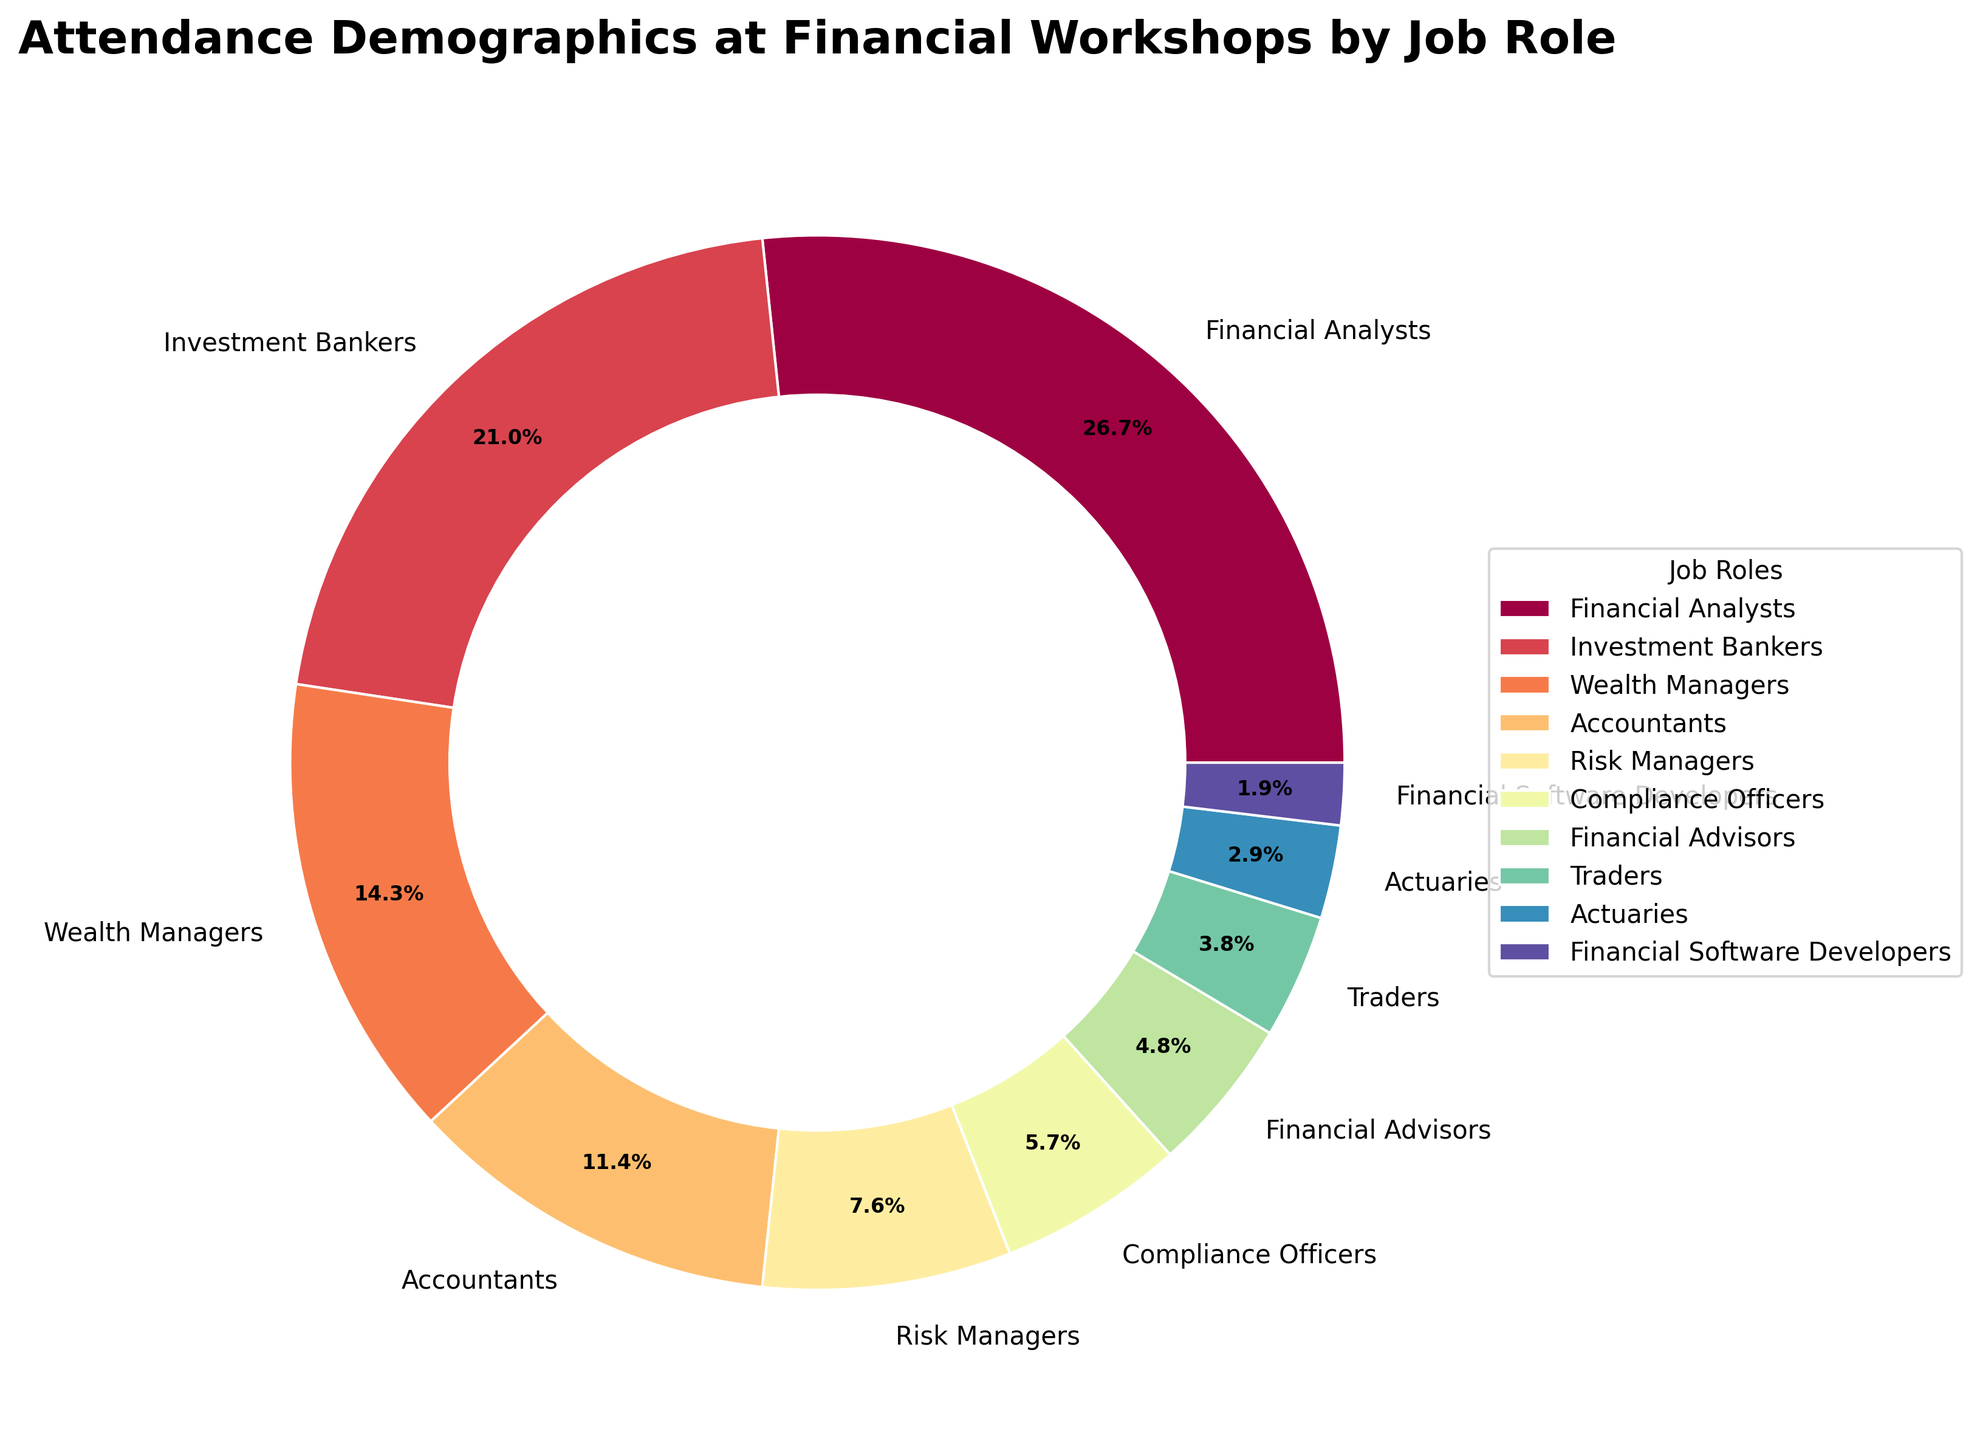What's the percentage of Financial Analysts attending the workshops? From the pie chart, the label next to "Financial Analysts" shows the percentage as 28%. No additional operations or calculations are needed.
Answer: 28% Which job role has the lowest percentage of attendance? From the pie chart, the label with the smallest percentage is "Financial Software Developers" with 2%. This is evident from the size of the wedge and the label associated with it.
Answer: Financial Software Developers What is the combined percentage of Financial Analysts and Investment Bankers? From the pie chart, the percentage of Financial Analysts is 28% and Investment Bankers is 22%. Adding these two percentages together: 28% + 22% = 50%.
Answer: 50% Which job role has a higher attendance percentage: Wealth Managers or Accountants? From the pie chart, the percentage for Wealth Managers is 15% and for Accountants is 12%. Comparing these two values, Wealth Managers have a higher attendance percentage.
Answer: Wealth Managers Are there more Wealth Managers or Compliance Officers attending the workshops? Comparing the percentages from the pie chart, Wealth Managers have 15% while Compliance Officers have 6%. Thus, there are more Wealth Managers attending.
Answer: Wealth Managers What is the total percentage of attendance for job roles with less than 10% each? From the pie chart, the roles with less than 10% attendance are: Risk Managers (8%), Compliance Officers (6%), Financial Advisors (5%), Traders (4%), Actuaries (3%), and Financial Software Developers (2%). Adding these gives: 8% + 6% + 5% + 4% + 3% + 2% = 28%.
Answer: 28% Compare the attendance percentage between Wealth Managers and all job roles with less than 5% attendance combined. Wealth Managers alone have 15%. Job roles with less than 5% attendance are Traders (4%), Actuaries (3%), and Financial Software Developers (2%), combined these percentages are 4% + 3% + 2% = 9%. Thus, Wealth Managers (15%) have a higher attendance than these combined.
Answer: Wealth Managers What's the range of attendance percentages across all job roles? The highest percentage is for Financial Analysts at 28% and the lowest is for Financial Software Developers at 2%. The range is calculated as the difference between the highest and lowest percentages (28% - 2% = 26%).
Answer: 26% Which job role occupies a visually distinct segment near the top of the pie chart based on color? The segments are colored uniquely, and a visual inspection of the segments and their labels shows that Investment Bankers, which is one of the larger segments, has a distinct color and is nearer to the top.
Answer: Investment Bankers Is there a job role with a percentage that is exactly double another job role's percentage? If so, name them. From the pie chart, we can compare the percentages. Wealth Managers have 15% which is exactly double that of Financial Advisors with 5%.
Answer: Wealth Managers and Financial Advisors 